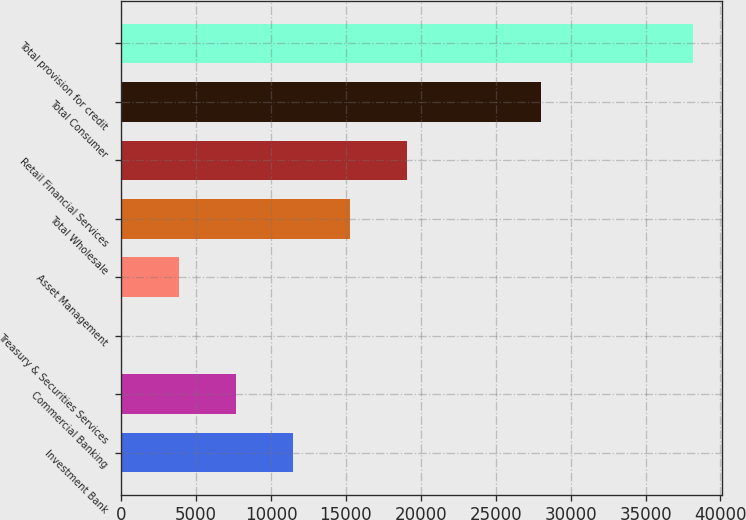<chart> <loc_0><loc_0><loc_500><loc_500><bar_chart><fcel>Investment Bank<fcel>Commercial Banking<fcel>Treasury & Securities Services<fcel>Asset Management<fcel>Total Wholesale<fcel>Retail Financial Services<fcel>Total Consumer<fcel>Total provision for credit<nl><fcel>11477.2<fcel>7662.8<fcel>34<fcel>3848.4<fcel>15291.6<fcel>19106<fcel>28051<fcel>38178<nl></chart> 